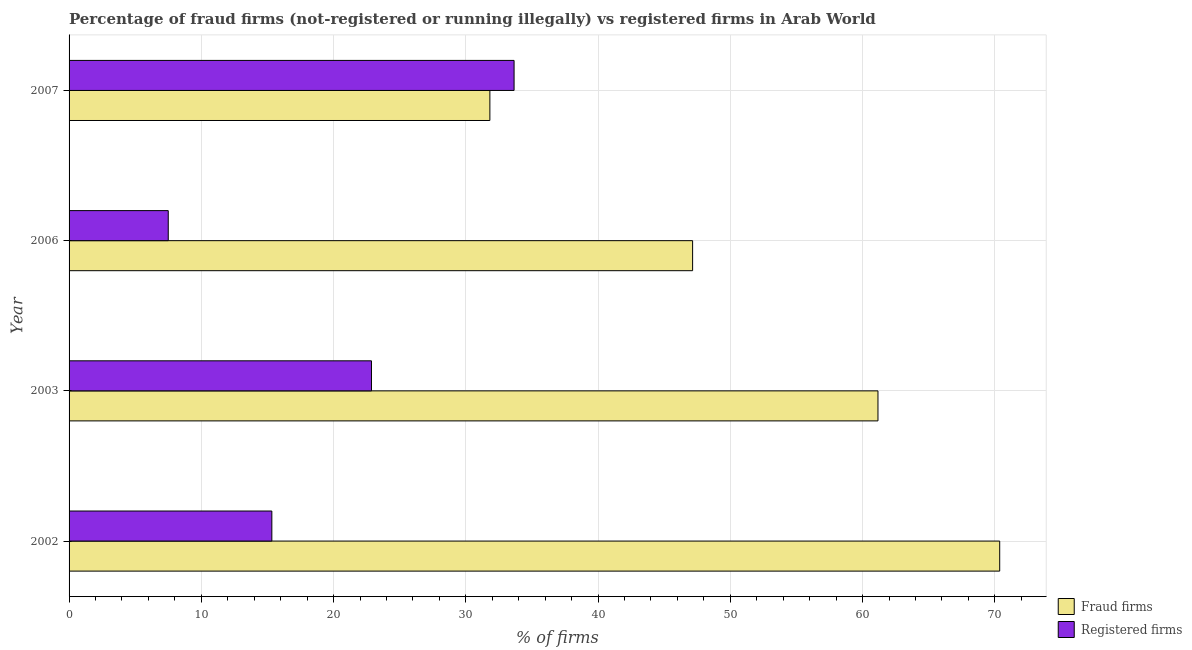How many different coloured bars are there?
Your answer should be very brief. 2. How many groups of bars are there?
Offer a very short reply. 4. How many bars are there on the 4th tick from the top?
Offer a terse response. 2. What is the label of the 4th group of bars from the top?
Your answer should be compact. 2002. What is the percentage of fraud firms in 2007?
Ensure brevity in your answer.  31.82. Across all years, what is the maximum percentage of registered firms?
Your answer should be compact. 33.65. In which year was the percentage of fraud firms maximum?
Give a very brief answer. 2002. What is the total percentage of fraud firms in the graph?
Provide a short and direct response. 210.5. What is the difference between the percentage of registered firms in 2003 and that in 2007?
Ensure brevity in your answer.  -10.78. What is the difference between the percentage of registered firms in 2003 and the percentage of fraud firms in 2007?
Your response must be concise. -8.95. What is the average percentage of registered firms per year?
Offer a very short reply. 19.84. In the year 2003, what is the difference between the percentage of registered firms and percentage of fraud firms?
Your response must be concise. -38.3. In how many years, is the percentage of fraud firms greater than 28 %?
Provide a succinct answer. 4. What is the ratio of the percentage of registered firms in 2002 to that in 2007?
Offer a terse response. 0.46. Is the percentage of fraud firms in 2006 less than that in 2007?
Keep it short and to the point. No. Is the difference between the percentage of registered firms in 2002 and 2007 greater than the difference between the percentage of fraud firms in 2002 and 2007?
Offer a very short reply. No. What is the difference between the highest and the second highest percentage of fraud firms?
Make the answer very short. 9.21. What is the difference between the highest and the lowest percentage of fraud firms?
Your answer should be compact. 38.55. In how many years, is the percentage of registered firms greater than the average percentage of registered firms taken over all years?
Keep it short and to the point. 2. Is the sum of the percentage of registered firms in 2003 and 2006 greater than the maximum percentage of fraud firms across all years?
Offer a terse response. No. What does the 2nd bar from the top in 2003 represents?
Provide a short and direct response. Fraud firms. What does the 1st bar from the bottom in 2006 represents?
Provide a succinct answer. Fraud firms. How many bars are there?
Ensure brevity in your answer.  8. How many years are there in the graph?
Keep it short and to the point. 4. Are the values on the major ticks of X-axis written in scientific E-notation?
Keep it short and to the point. No. Does the graph contain any zero values?
Offer a terse response. No. Does the graph contain grids?
Keep it short and to the point. Yes. Where does the legend appear in the graph?
Keep it short and to the point. Bottom right. What is the title of the graph?
Offer a very short reply. Percentage of fraud firms (not-registered or running illegally) vs registered firms in Arab World. What is the label or title of the X-axis?
Give a very brief answer. % of firms. What is the % of firms of Fraud firms in 2002?
Provide a short and direct response. 70.37. What is the % of firms of Registered firms in 2002?
Your answer should be compact. 15.33. What is the % of firms of Fraud firms in 2003?
Make the answer very short. 61.16. What is the % of firms of Registered firms in 2003?
Your response must be concise. 22.87. What is the % of firms in Fraud firms in 2006?
Your answer should be compact. 47.15. What is the % of firms of Fraud firms in 2007?
Make the answer very short. 31.82. What is the % of firms in Registered firms in 2007?
Your answer should be compact. 33.65. Across all years, what is the maximum % of firms in Fraud firms?
Keep it short and to the point. 70.37. Across all years, what is the maximum % of firms of Registered firms?
Make the answer very short. 33.65. Across all years, what is the minimum % of firms in Fraud firms?
Make the answer very short. 31.82. Across all years, what is the minimum % of firms in Registered firms?
Provide a succinct answer. 7.5. What is the total % of firms in Fraud firms in the graph?
Provide a succinct answer. 210.5. What is the total % of firms in Registered firms in the graph?
Give a very brief answer. 79.35. What is the difference between the % of firms of Fraud firms in 2002 and that in 2003?
Provide a succinct answer. 9.21. What is the difference between the % of firms in Registered firms in 2002 and that in 2003?
Offer a very short reply. -7.53. What is the difference between the % of firms in Fraud firms in 2002 and that in 2006?
Your response must be concise. 23.22. What is the difference between the % of firms of Registered firms in 2002 and that in 2006?
Your response must be concise. 7.83. What is the difference between the % of firms of Fraud firms in 2002 and that in 2007?
Give a very brief answer. 38.55. What is the difference between the % of firms in Registered firms in 2002 and that in 2007?
Provide a succinct answer. -18.32. What is the difference between the % of firms in Fraud firms in 2003 and that in 2006?
Ensure brevity in your answer.  14.02. What is the difference between the % of firms of Registered firms in 2003 and that in 2006?
Offer a very short reply. 15.37. What is the difference between the % of firms in Fraud firms in 2003 and that in 2007?
Provide a succinct answer. 29.34. What is the difference between the % of firms in Registered firms in 2003 and that in 2007?
Ensure brevity in your answer.  -10.78. What is the difference between the % of firms in Fraud firms in 2006 and that in 2007?
Offer a very short reply. 15.33. What is the difference between the % of firms of Registered firms in 2006 and that in 2007?
Offer a terse response. -26.15. What is the difference between the % of firms in Fraud firms in 2002 and the % of firms in Registered firms in 2003?
Your answer should be compact. 47.5. What is the difference between the % of firms in Fraud firms in 2002 and the % of firms in Registered firms in 2006?
Your answer should be very brief. 62.87. What is the difference between the % of firms of Fraud firms in 2002 and the % of firms of Registered firms in 2007?
Give a very brief answer. 36.72. What is the difference between the % of firms of Fraud firms in 2003 and the % of firms of Registered firms in 2006?
Give a very brief answer. 53.66. What is the difference between the % of firms of Fraud firms in 2003 and the % of firms of Registered firms in 2007?
Give a very brief answer. 27.52. What is the difference between the % of firms of Fraud firms in 2006 and the % of firms of Registered firms in 2007?
Offer a very short reply. 13.5. What is the average % of firms in Fraud firms per year?
Ensure brevity in your answer.  52.63. What is the average % of firms in Registered firms per year?
Offer a terse response. 19.84. In the year 2002, what is the difference between the % of firms in Fraud firms and % of firms in Registered firms?
Your answer should be compact. 55.04. In the year 2003, what is the difference between the % of firms in Fraud firms and % of firms in Registered firms?
Give a very brief answer. 38.3. In the year 2006, what is the difference between the % of firms of Fraud firms and % of firms of Registered firms?
Offer a very short reply. 39.65. In the year 2007, what is the difference between the % of firms in Fraud firms and % of firms in Registered firms?
Your answer should be compact. -1.83. What is the ratio of the % of firms of Fraud firms in 2002 to that in 2003?
Make the answer very short. 1.15. What is the ratio of the % of firms in Registered firms in 2002 to that in 2003?
Ensure brevity in your answer.  0.67. What is the ratio of the % of firms of Fraud firms in 2002 to that in 2006?
Ensure brevity in your answer.  1.49. What is the ratio of the % of firms of Registered firms in 2002 to that in 2006?
Offer a very short reply. 2.04. What is the ratio of the % of firms in Fraud firms in 2002 to that in 2007?
Your response must be concise. 2.21. What is the ratio of the % of firms of Registered firms in 2002 to that in 2007?
Provide a succinct answer. 0.46. What is the ratio of the % of firms of Fraud firms in 2003 to that in 2006?
Your response must be concise. 1.3. What is the ratio of the % of firms of Registered firms in 2003 to that in 2006?
Provide a succinct answer. 3.05. What is the ratio of the % of firms of Fraud firms in 2003 to that in 2007?
Provide a succinct answer. 1.92. What is the ratio of the % of firms in Registered firms in 2003 to that in 2007?
Provide a short and direct response. 0.68. What is the ratio of the % of firms in Fraud firms in 2006 to that in 2007?
Offer a terse response. 1.48. What is the ratio of the % of firms of Registered firms in 2006 to that in 2007?
Provide a succinct answer. 0.22. What is the difference between the highest and the second highest % of firms in Fraud firms?
Ensure brevity in your answer.  9.21. What is the difference between the highest and the second highest % of firms of Registered firms?
Ensure brevity in your answer.  10.78. What is the difference between the highest and the lowest % of firms in Fraud firms?
Offer a very short reply. 38.55. What is the difference between the highest and the lowest % of firms in Registered firms?
Your answer should be very brief. 26.15. 